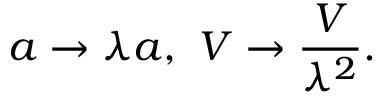<formula> <loc_0><loc_0><loc_500><loc_500>a \to \lambda a , \ V \to \frac { V } { \lambda ^ { 2 } } .</formula> 